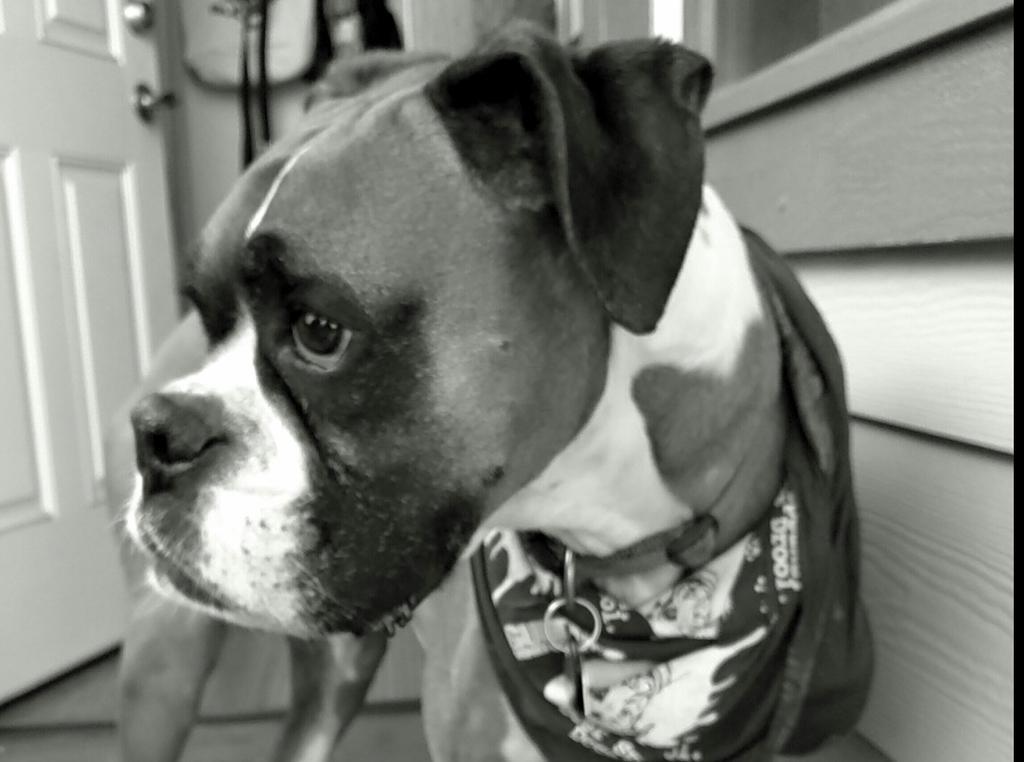Please provide a concise description of this image. This is a black and white image. In this image we can see a dog standing on the floor. 